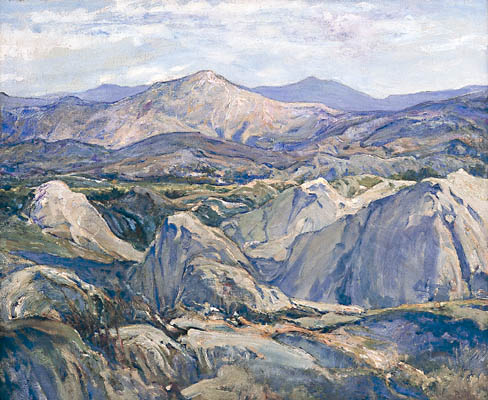What emotions does this painting evoke? The painting evokes a sense of tranquility and awe. The serene depiction of the mountains and valleys, with the soft hues and impressionistic brushstrokes, suggests a world untouched by the rush of modern life. There is a quiet majesty to the mountains in the distance, which, combined with the softer, rolling hills in the foreground, creates a feeling of peaceful solitude. It's a scene that invites contemplation and a deeper connection with nature. 